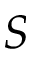<formula> <loc_0><loc_0><loc_500><loc_500>S</formula> 